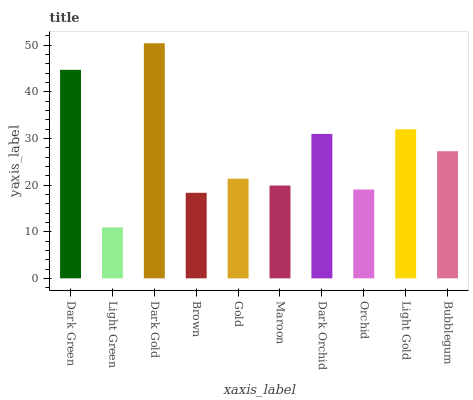Is Dark Gold the minimum?
Answer yes or no. No. Is Light Green the maximum?
Answer yes or no. No. Is Dark Gold greater than Light Green?
Answer yes or no. Yes. Is Light Green less than Dark Gold?
Answer yes or no. Yes. Is Light Green greater than Dark Gold?
Answer yes or no. No. Is Dark Gold less than Light Green?
Answer yes or no. No. Is Bubblegum the high median?
Answer yes or no. Yes. Is Gold the low median?
Answer yes or no. Yes. Is Dark Gold the high median?
Answer yes or no. No. Is Light Gold the low median?
Answer yes or no. No. 